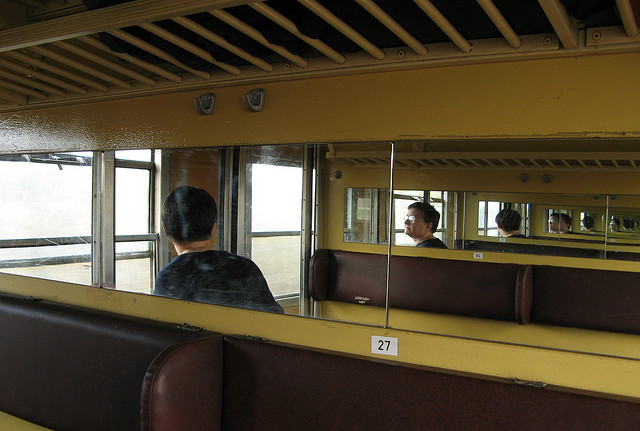<image>Why is the number 27 on the wall? I don't know why the number 27 is on the wall. It could be a seat or section number. Why is the number 27 on the wall? It is unknown why the number 27 is on the wall. It can be a seat number, section number, seating, booth label, or seat row number. 